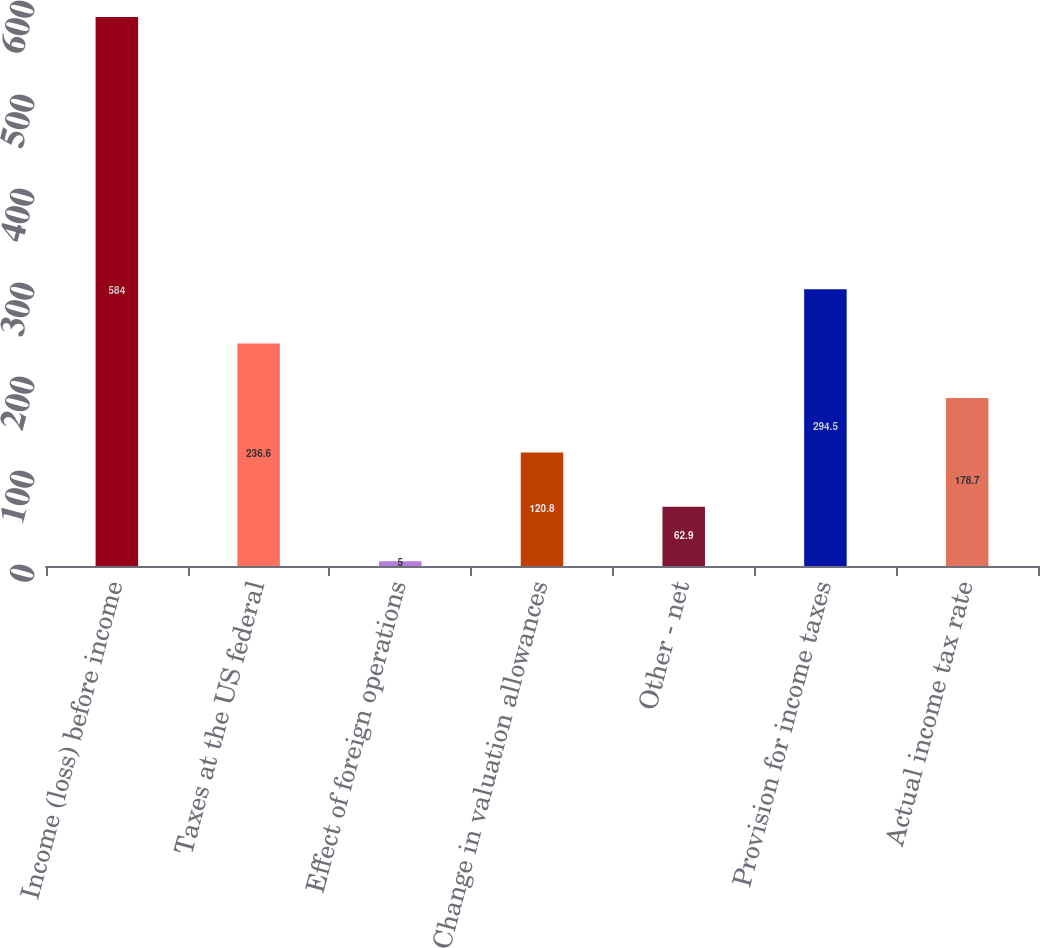Convert chart to OTSL. <chart><loc_0><loc_0><loc_500><loc_500><bar_chart><fcel>Income (loss) before income<fcel>Taxes at the US federal<fcel>Effect of foreign operations<fcel>Change in valuation allowances<fcel>Other - net<fcel>Provision for income taxes<fcel>Actual income tax rate<nl><fcel>584<fcel>236.6<fcel>5<fcel>120.8<fcel>62.9<fcel>294.5<fcel>178.7<nl></chart> 